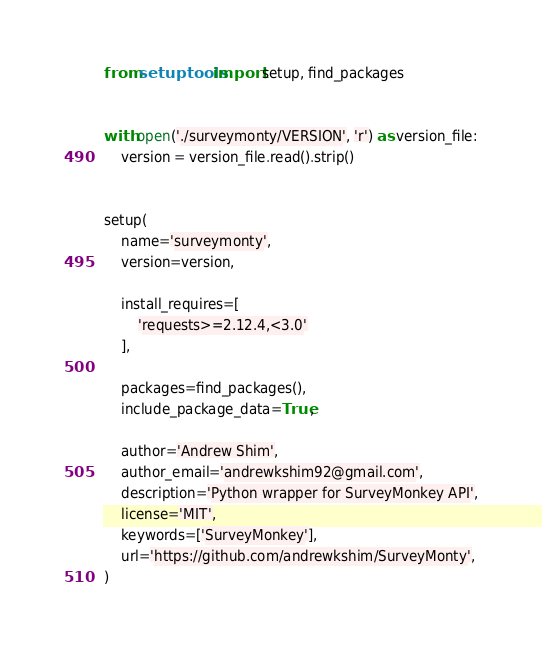<code> <loc_0><loc_0><loc_500><loc_500><_Python_>from setuptools import setup, find_packages


with open('./surveymonty/VERSION', 'r') as version_file:
    version = version_file.read().strip()


setup(
    name='surveymonty',
    version=version,

    install_requires=[
        'requests>=2.12.4,<3.0'
    ],

    packages=find_packages(),
    include_package_data=True,

    author='Andrew Shim',
    author_email='andrewkshim92@gmail.com',
    description='Python wrapper for SurveyMonkey API',
    license='MIT',
    keywords=['SurveyMonkey'],
    url='https://github.com/andrewkshim/SurveyMonty',
)
</code> 